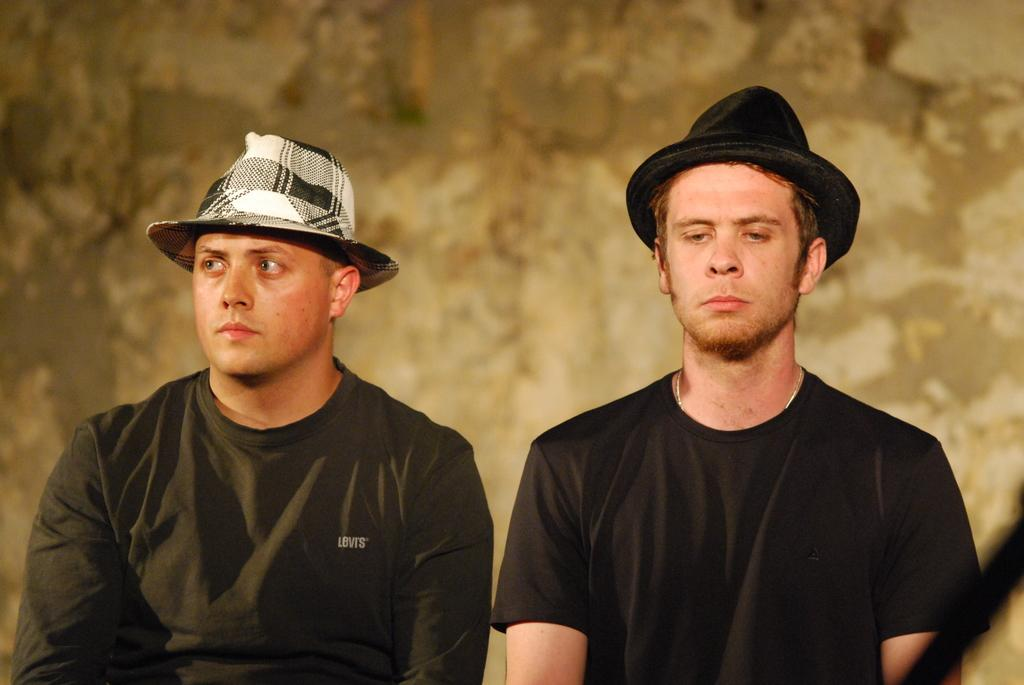How many people are in the image? There are two men in the image. What are the men wearing on their heads? Both men are wearing hats. What color are the t-shirts worn by the men? Both men are wearing black color t-shirts. Can you describe the background of the image? There is a brown color thing in the background of the image. What is the sister of the men doing in the image? There is no mention of a sister in the image or the provided facts. --- 